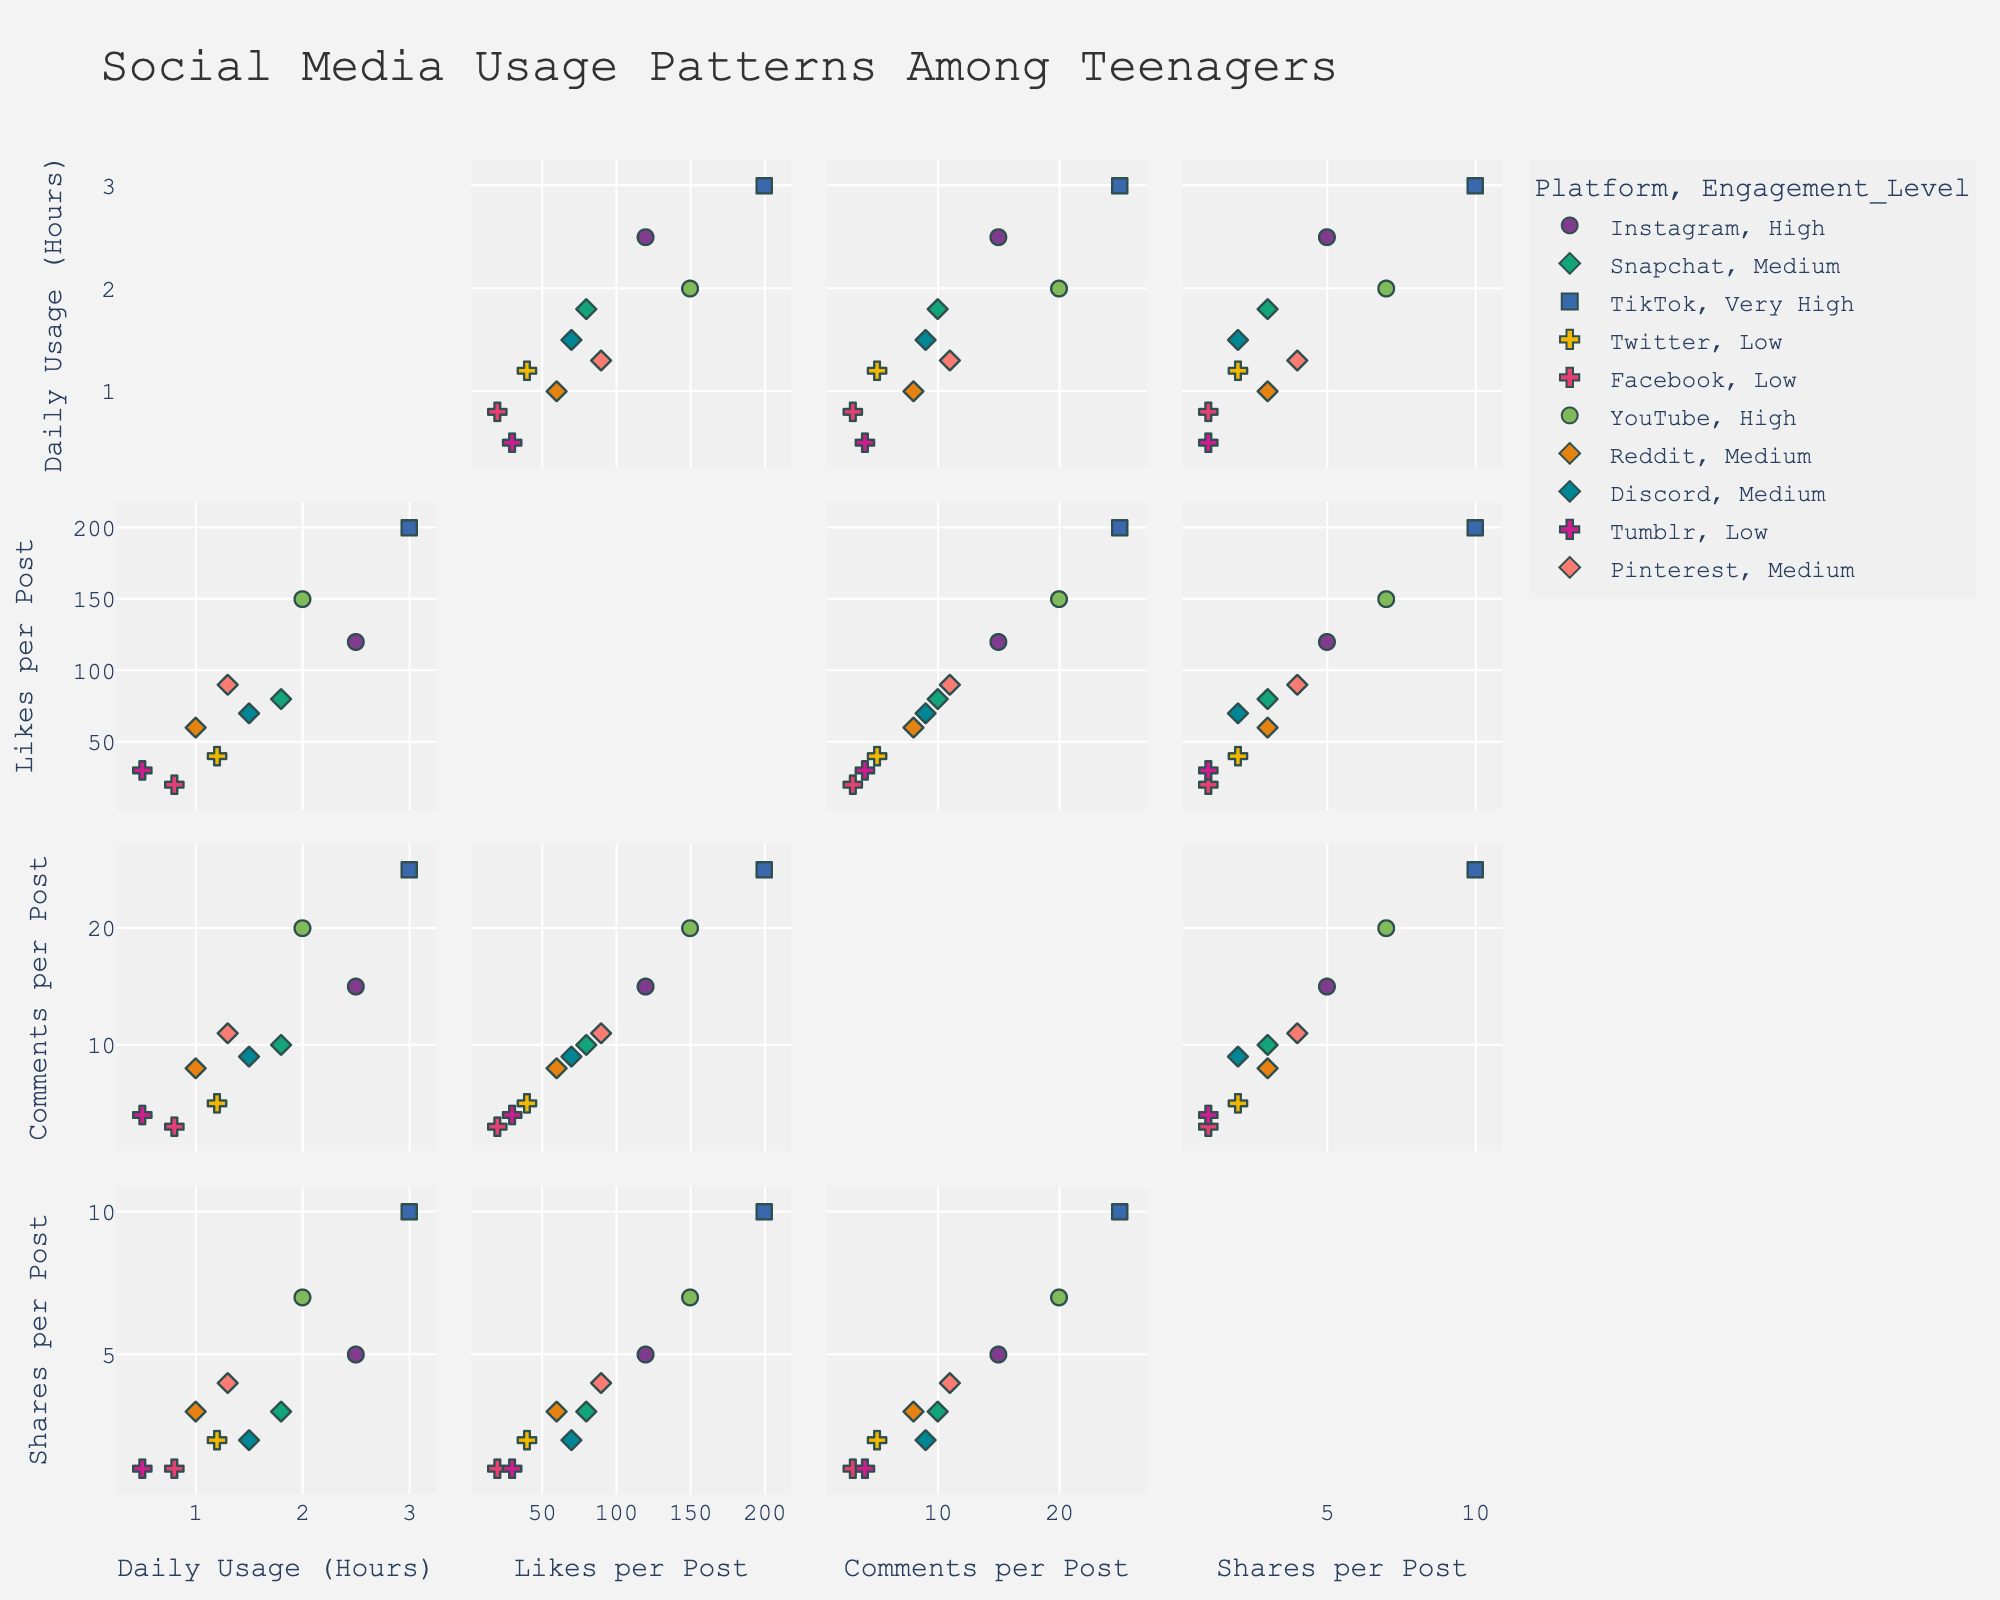Which platform shows the highest daily usage hours? Look at the "Daily Usage (Hours)" axis and identify the platform with the highest value in that column. TikTok is the platform with the highest daily usage of 3.0 hours.
Answer: TikTok Which platform has the lowest engagement level based on comments per post? Check the "Comments per Post" axis and locate the platform with the lowest value. Facebook has the lowest engagement level with only 3 comments per post.
Answer: Facebook What is the average daily usage hour across all platforms? Identify the "Daily Usage (Hours)" values for each platform: [2.5, 1.8, 3.0, 1.2, 0.8, 2.0, 1.0, 1.5, 0.5, 1.3]. Sum these values and divide by the number of platforms: (2.5+1.8+3.0+1.2+0.8+2.0+1.0+1.5+0.5+1.3)/10 = 15.6/10 = 1.56 hours.
Answer: 1.56 hours Which platform has the highest number of likes per post? Look at the "Likes per Post" axis and identify the platform with the highest value. TikTok has the highest likes per post with 200 likes.
Answer: TikTok How do the daily usage hours of Instagram and YouTube compare? Compare the "Daily Usage (Hours)" values for Instagram and YouTube. Instagram has 2.5 hours and YouTube has 2.0 hours, so Instagram has higher daily usage.
Answer: Instagram > YouTube Which platform has the most balanced engagement level in terms of likes, comments, and shares per post? To find the platform with balanced engagement, look for platforms with medium range values in "Likes per Post," "Comments per Post," and "Shares per Post." Pinterest has medium values of 90 likes, 11 comments, and 4 shares per post, making it the most balanced.
Answer: Pinterest What's the total number of comments per post for all low engagement level platforms? Identify the platforms with low engagement levels: Twitter, Facebook, and Tumblr. Sum their "Comments per Post" values: 5 (Twitter) + 3 (Facebook) + 4 (Tumblr) = 5 + 3 + 4 = 12 comments.
Answer: 12 comments Which platform has relatively low daily usage but high engagement levels based on all metrics? Compare the "Daily Usage (Hours)" and "Engagement Level" for all platforms. YouTube has relatively low daily usage (2.0 hours) but high engagement levels in likes (150), comments (20), and shares (7).
Answer: YouTube Is there a correlation between daily usage hours and likes per post? Look at the scatter plot comparing "Daily Usage (Hours)" and "Likes per Post." Higher daily usage tends to correspond with higher likes per post, indicating a positive correlation.
Answer: Positive correlation 